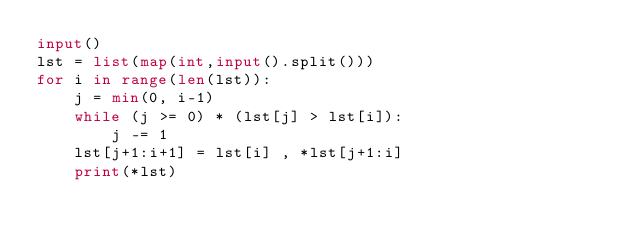<code> <loc_0><loc_0><loc_500><loc_500><_Python_>input()
lst = list(map(int,input().split()))
for i in range(len(lst)):
    j = min(0, i-1)
    while (j >= 0) * (lst[j] > lst[i]):
        j -= 1
    lst[j+1:i+1] = lst[i] , *lst[j+1:i]
    print(*lst)</code> 